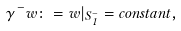Convert formula to latex. <formula><loc_0><loc_0><loc_500><loc_500>\gamma ^ { - } w \colon = w | _ { S _ { 1 } ^ { - } } = c o n s t a n t ,</formula> 